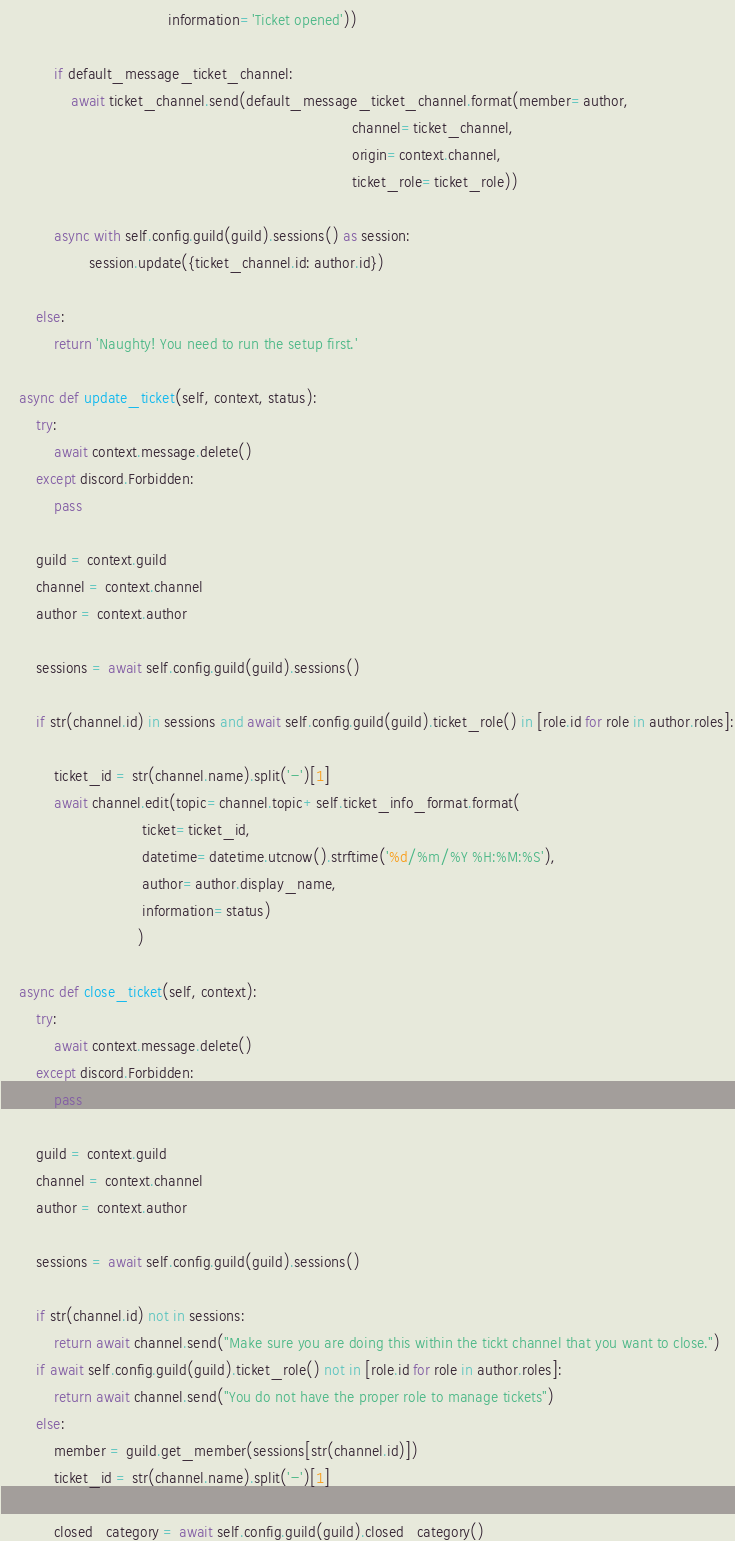<code> <loc_0><loc_0><loc_500><loc_500><_Python_>                                      information='Ticket opened'))

            if default_message_ticket_channel:
                await ticket_channel.send(default_message_ticket_channel.format(member=author,
                                                                                channel=ticket_channel,
                                                                                origin=context.channel,
                                                                                ticket_role=ticket_role))

            async with self.config.guild(guild).sessions() as session:
                    session.update({ticket_channel.id: author.id})

        else:
            return 'Naughty! You need to run the setup first.'

    async def update_ticket(self, context, status):
        try:
            await context.message.delete()
        except discord.Forbidden:
            pass

        guild = context.guild
        channel = context.channel
        author = context.author

        sessions = await self.config.guild(guild).sessions()

        if str(channel.id) in sessions and await self.config.guild(guild).ticket_role() in [role.id for role in author.roles]:

            ticket_id = str(channel.name).split('-')[1]
            await channel.edit(topic=channel.topic+self.ticket_info_format.format(
                                ticket=ticket_id,
                                datetime=datetime.utcnow().strftime('%d/%m/%Y %H:%M:%S'),
                                author=author.display_name,
                                information=status)
                               )

    async def close_ticket(self, context):
        try:
            await context.message.delete()
        except discord.Forbidden:
            pass

        guild = context.guild
        channel = context.channel
        author = context.author

        sessions = await self.config.guild(guild).sessions()

        if str(channel.id) not in sessions:
            return await channel.send("Make sure you are doing this within the tickt channel that you want to close.")
        if await self.config.guild(guild).ticket_role() not in [role.id for role in author.roles]:
            return await channel.send("You do not have the proper role to manage tickets")
        else:
            member = guild.get_member(sessions[str(channel.id)])
            ticket_id = str(channel.name).split('-')[1]

            closed_category = await self.config.guild(guild).closed_category()</code> 